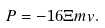<formula> <loc_0><loc_0><loc_500><loc_500>P = - 1 6 \Xi m v .</formula> 